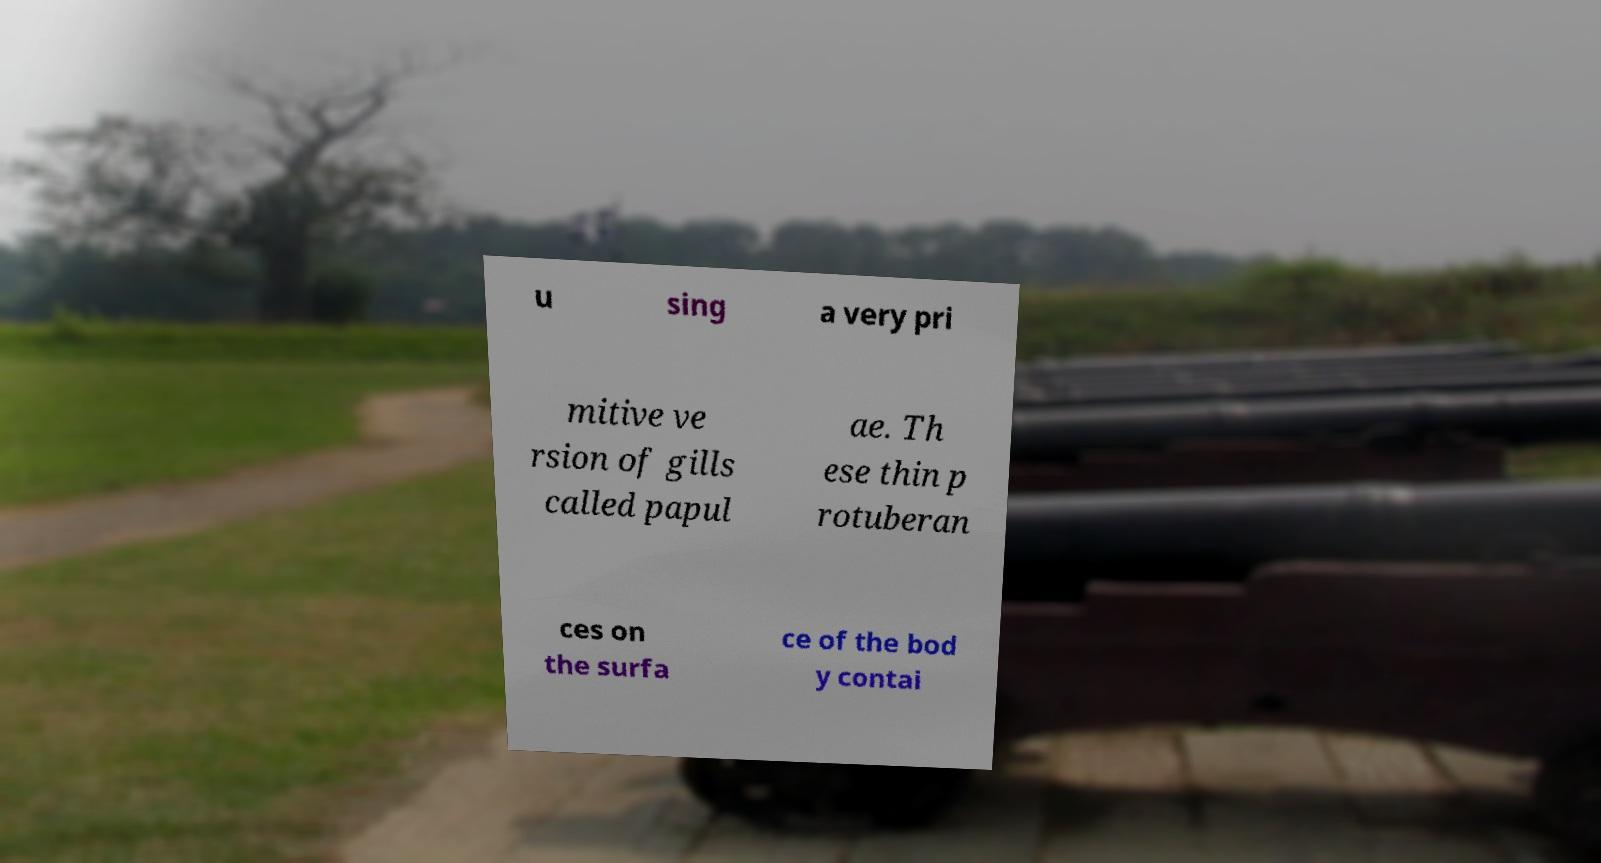Could you assist in decoding the text presented in this image and type it out clearly? u sing a very pri mitive ve rsion of gills called papul ae. Th ese thin p rotuberan ces on the surfa ce of the bod y contai 